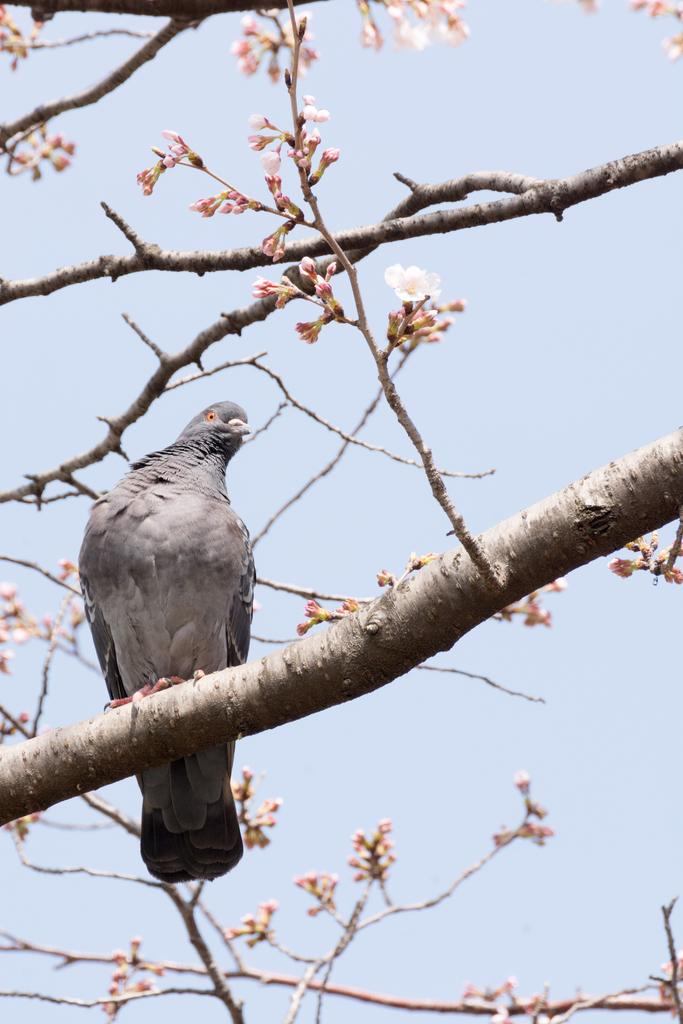What type of animal can be seen in the image? There is a bird in the image. Where is the bird located? The bird is on the branch of a tree. What can be seen in the background of the image? There is sky visible in the background of the image. How many friends does the bird have in the image? There is no information about friends in the image, as it only features a bird on a tree branch. 